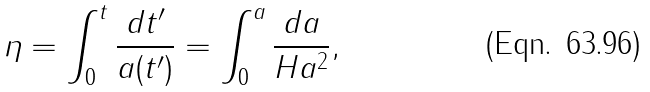<formula> <loc_0><loc_0><loc_500><loc_500>\eta = \int ^ { t } _ { 0 } { \frac { d t ^ { \prime } } { a ( t ^ { \prime } ) } } = \int ^ { a } _ { 0 } { \frac { d a } { H a ^ { 2 } } } ,</formula> 